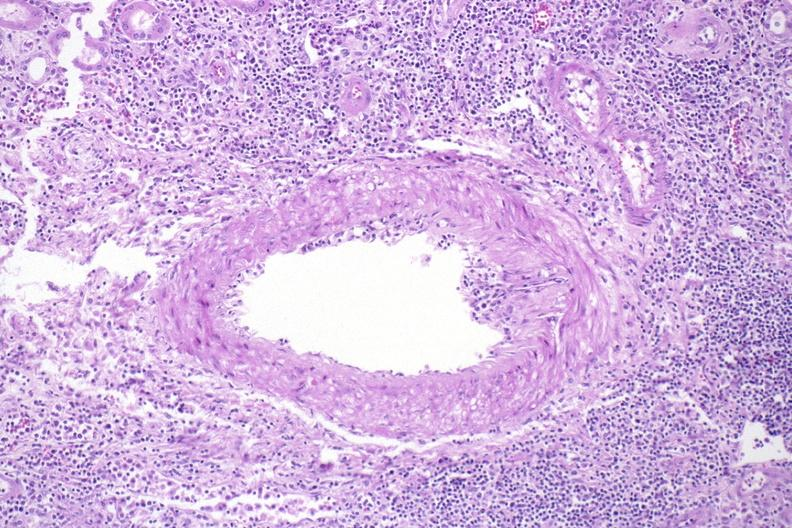what does this image show?
Answer the question using a single word or phrase. Kidney 